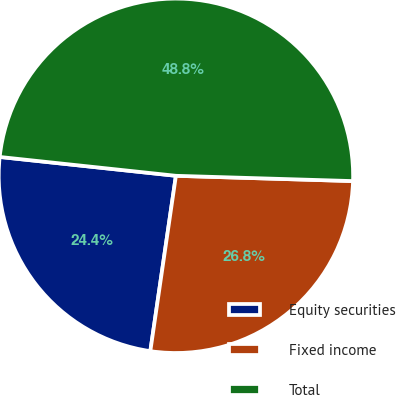Convert chart. <chart><loc_0><loc_0><loc_500><loc_500><pie_chart><fcel>Equity securities<fcel>Fixed income<fcel>Total<nl><fcel>24.39%<fcel>26.83%<fcel>48.78%<nl></chart> 